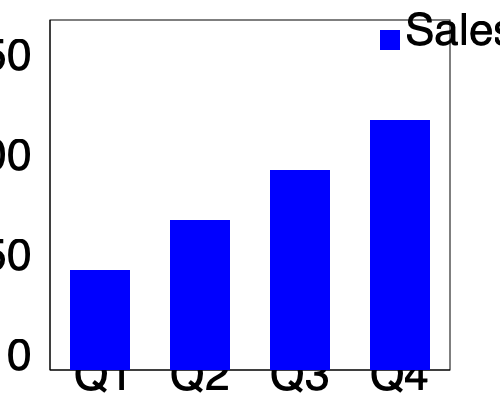As an entrepreneur analyzing sales data, what is the percentage increase in sales from Q1 to Q4 based on the 3D bar graph representing quarterly sales? To calculate the percentage increase in sales from Q1 to Q4, we need to follow these steps:

1. Identify the sales values for Q1 and Q4:
   - Q1 sales: 50 units (bar height is 100 pixels, which represents 50 units on the y-axis)
   - Q4 sales: 125 units (bar height is 250 pixels, which represents 125 units on the y-axis)

2. Calculate the difference in sales:
   Increase = Q4 sales - Q1 sales
   Increase = 125 - 50 = 75 units

3. Calculate the percentage increase:
   Percentage increase = (Increase / Original Value) × 100
   Percentage increase = (75 / 50) × 100 = 1.5 × 100 = 150%

Therefore, the percentage increase in sales from Q1 to Q4 is 150%.
Answer: 150% 